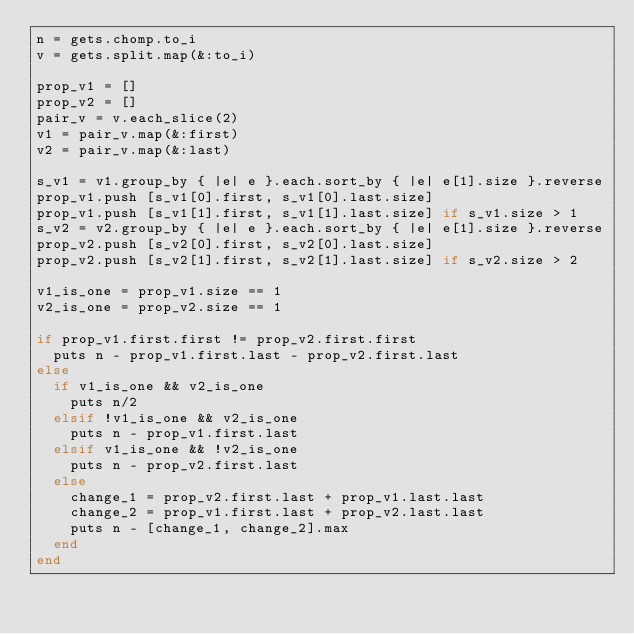<code> <loc_0><loc_0><loc_500><loc_500><_Ruby_>n = gets.chomp.to_i
v = gets.split.map(&:to_i)

prop_v1 = []
prop_v2 = []
pair_v = v.each_slice(2)
v1 = pair_v.map(&:first)
v2 = pair_v.map(&:last)

s_v1 = v1.group_by { |e| e }.each.sort_by { |e| e[1].size }.reverse
prop_v1.push [s_v1[0].first, s_v1[0].last.size]
prop_v1.push [s_v1[1].first, s_v1[1].last.size] if s_v1.size > 1
s_v2 = v2.group_by { |e| e }.each.sort_by { |e| e[1].size }.reverse
prop_v2.push [s_v2[0].first, s_v2[0].last.size]
prop_v2.push [s_v2[1].first, s_v2[1].last.size] if s_v2.size > 2

v1_is_one = prop_v1.size == 1
v2_is_one = prop_v2.size == 1

if prop_v1.first.first != prop_v2.first.first
  puts n - prop_v1.first.last - prop_v2.first.last
else
  if v1_is_one && v2_is_one
    puts n/2
  elsif !v1_is_one && v2_is_one
    puts n - prop_v1.first.last
  elsif v1_is_one && !v2_is_one
    puts n - prop_v2.first.last
  else
    change_1 = prop_v2.first.last + prop_v1.last.last
    change_2 = prop_v1.first.last + prop_v2.last.last
    puts n - [change_1, change_2].max
  end
end
</code> 